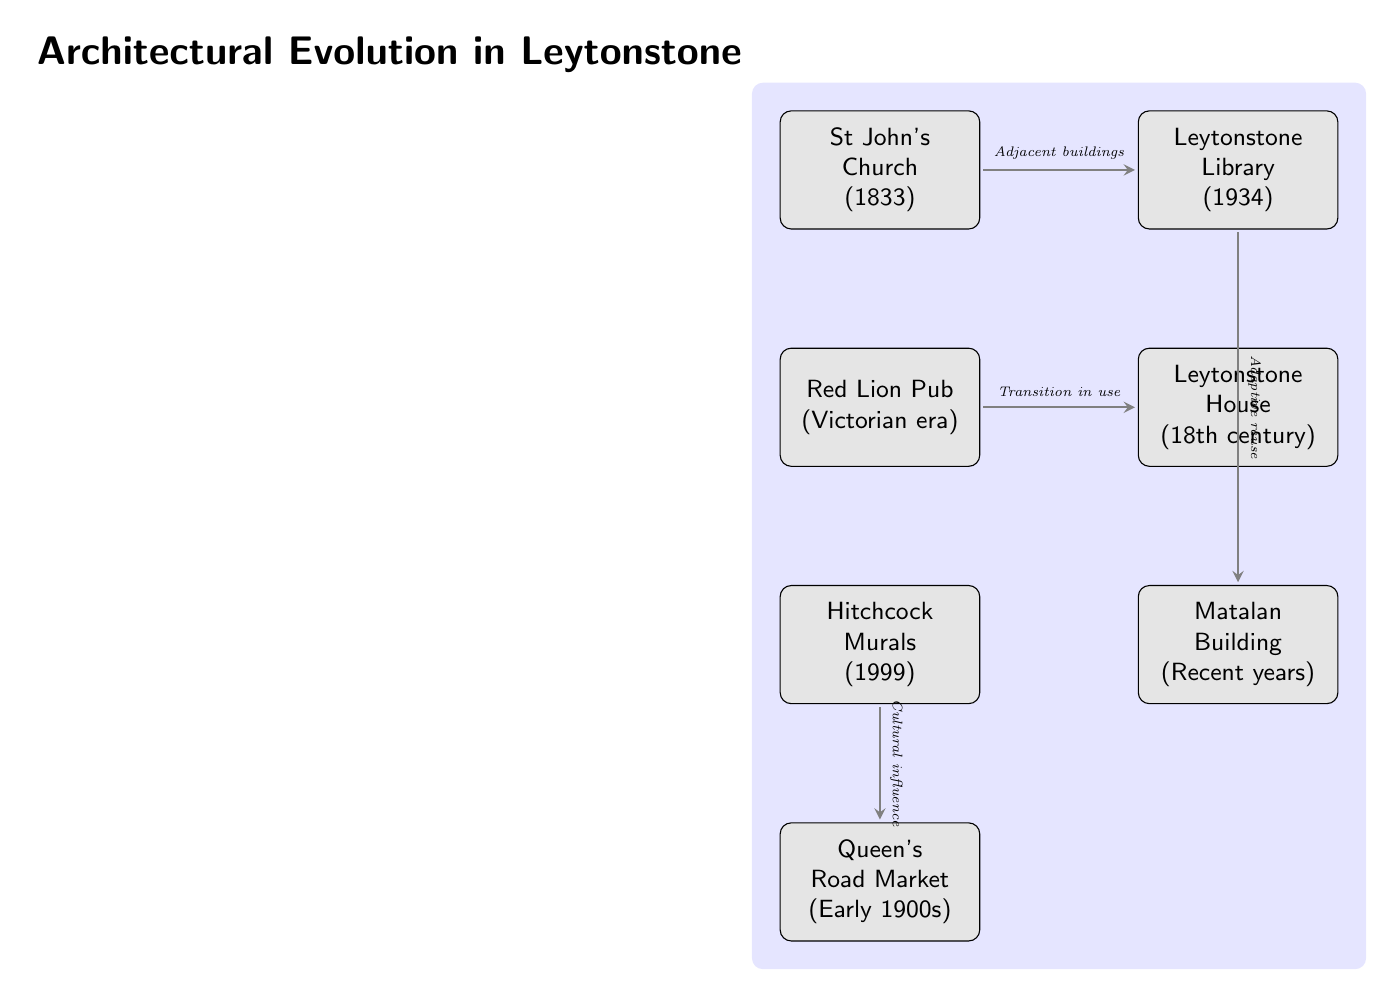What year was St John's Church built? The diagram labels St John's Church with the year it was built, which is shown directly beneath the name. It states "1833".
Answer: 1833 What building is adjacent to St John's Church? The diagram indicates that Leytonstone Library is adjacent to St John's Church through a directional connection marked "Adjacent buildings".
Answer: Leytonstone Library How many structures are mentioned in the diagram? By counting each labeled building node within the diagram, there are a total of six structures: St John's Church, Leytonstone Library, Red Lion Pub, Leytonstone House, Hitchcock Murals, and Matalan Building.
Answer: 6 Which structure reflects a cultural influence? The diagram shows an arrow from Hitchcock Murals to Queen's Road Market labeled "Cultural influence", indicating that Hitchcock Murals reflects a cultural influence.
Answer: Hitchcock Murals What type of building is Leytonstone House? The description under Leytonstone House states it is from the "18th century", which describes its architectural style and era.
Answer: 18th century Which two buildings indicate a transition in use? The diagram directs attention from Red Lion Pub to Leytonstone House with the label "Transition in use", linking these two buildings together through this concept.
Answer: Red Lion Pub and Leytonstone House What does the connection between Leytonstone Library and Matalan Building signify? The connection arrow between Leytonstone Library and Matalan Building is labeled "Adaptive reuse", which indicates the significance of how these structures have interacted in terms of their functionality.
Answer: Adaptive reuse What is the time period of the Red Lion Pub's architecture? The diagram specifies "Victorian era" beneath the Red Lion Pub node, indicating its architectural period.
Answer: Victorian era Which structure was established in recent years? Matalan Building is labeled "Recent years", which shows when it was established compared to the other buildings listed in the diagram.
Answer: Matalan Building 